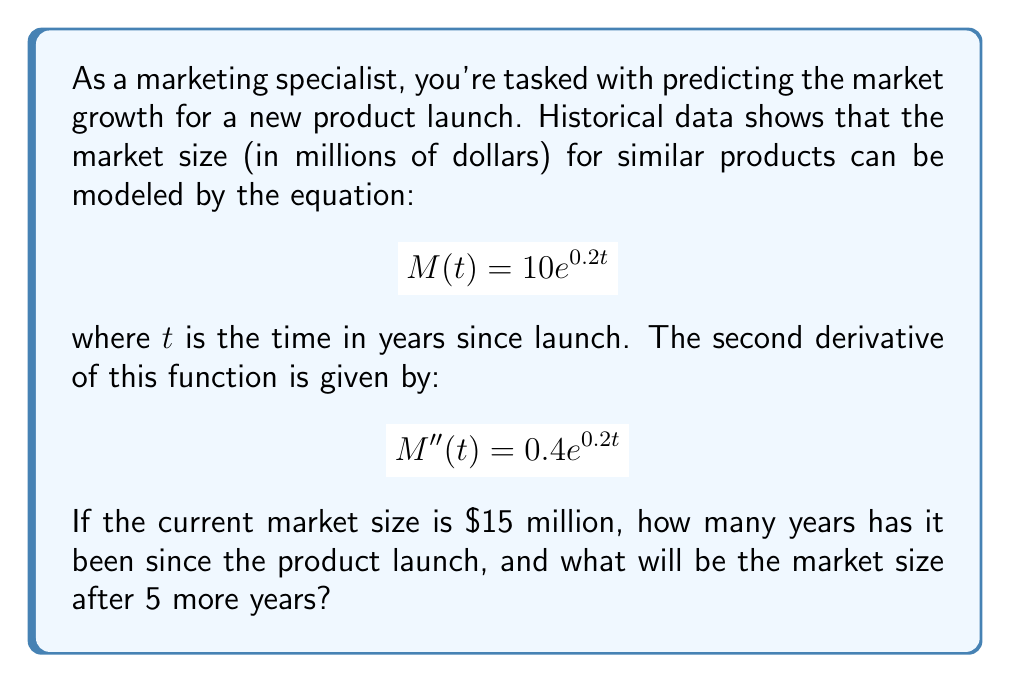Can you answer this question? Let's approach this step-by-step:

1) First, we need to find the current time $t$ since launch. We know that $M(t) = 15$ million:

   $$15 = 10e^{0.2t}$$

2) Dividing both sides by 10:

   $$1.5 = e^{0.2t}$$

3) Taking the natural log of both sides:

   $$\ln(1.5) = 0.2t$$

4) Solving for $t$:

   $$t = \frac{\ln(1.5)}{0.2} \approx 2.03$$

   So it's been about 2.03 years since the product launch.

5) To predict the market size after 5 more years, we need to calculate $M(2.03 + 5) = M(7.03)$:

   $$M(7.03) = 10e^{0.2(7.03)} \approx 41.1$$

6) The second derivative $M''(t) = 0.4e^{0.2t}$ represents the rate of change of the growth rate. It's always positive, indicating accelerating growth.
Answer: 2.03 years since launch; $41.1 million after 5 more years 